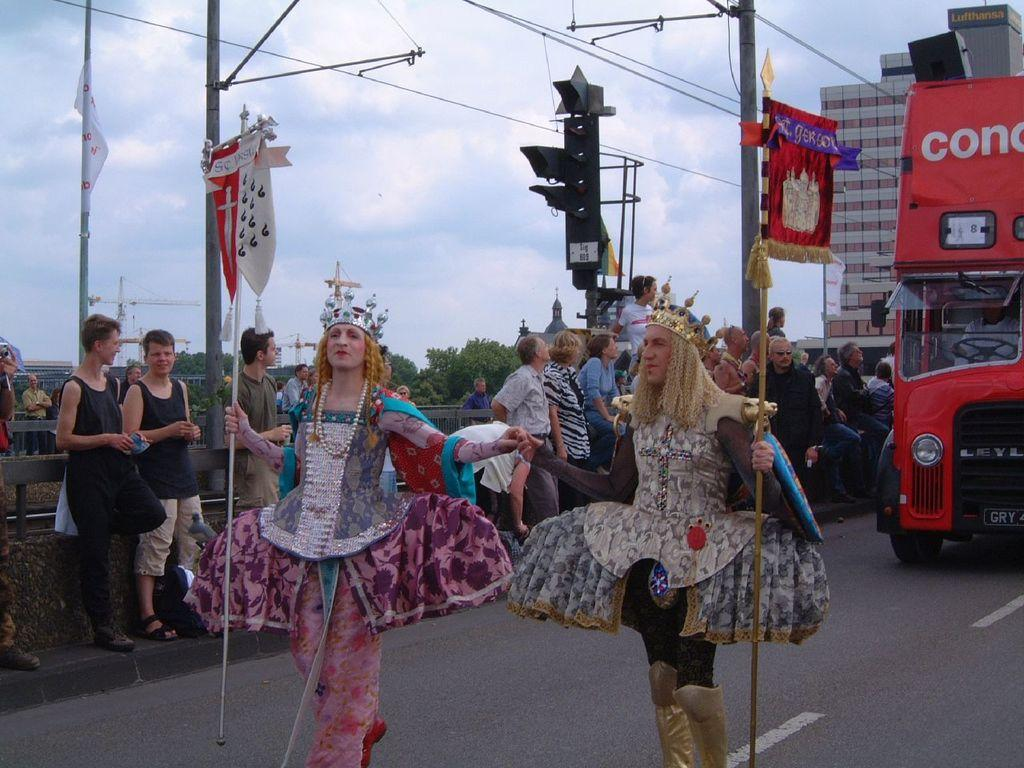Who or what can be seen in the image? There are people in the image. What is located on the right side of the image? There is a vehicle on the right side of the image. What can be seen in the distance in the image? There are buildings in the background of the image. What is visible in the sky in the background of the image? There are clouds in the sky in the background of the image. What grade does the whistle receive in the image? There is no whistle present in the image, so it cannot receive a grade. 